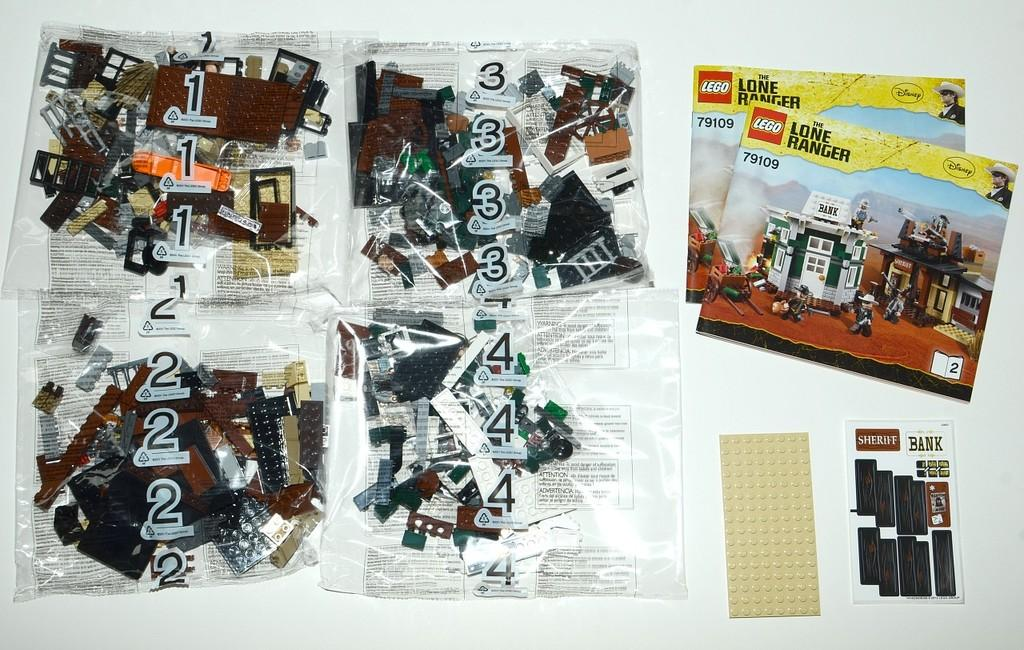What type of items can be seen in the image? There are books and lego toy packets in the image. Are there any other objects visible in the image? Yes, there are other objects in the image. What is the color of the background in the image? The background of the image is white. What type of substance is being spun into yarn in the image? There is no substance being spun into yarn in the image; it does not depict any yarn-making process. 